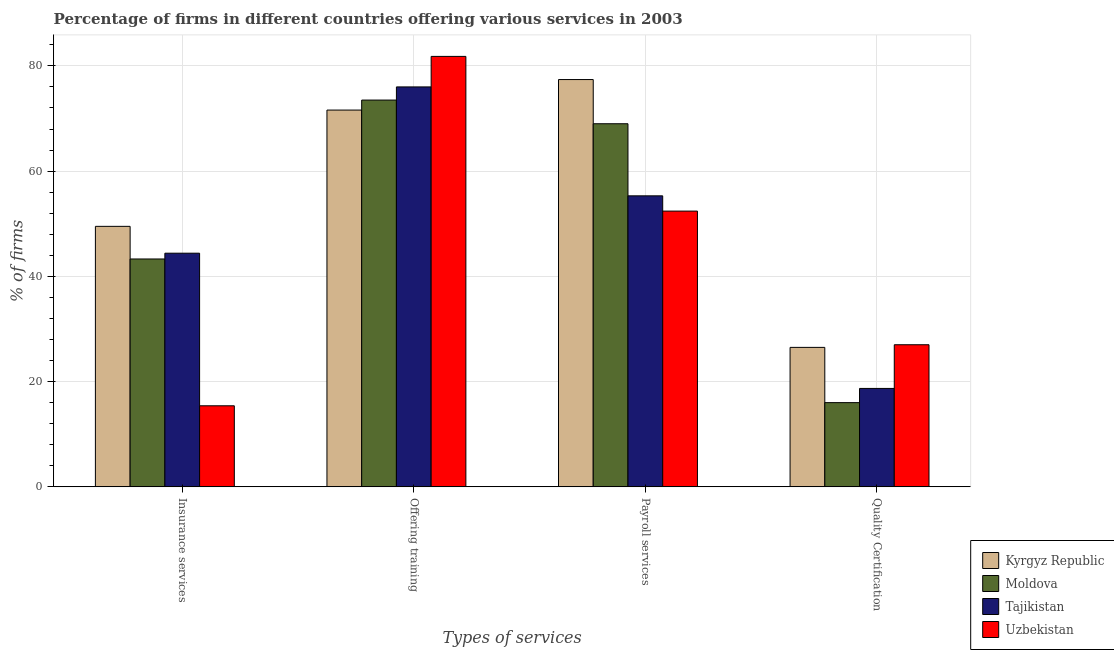How many different coloured bars are there?
Offer a terse response. 4. How many groups of bars are there?
Provide a succinct answer. 4. How many bars are there on the 3rd tick from the right?
Provide a succinct answer. 4. What is the label of the 3rd group of bars from the left?
Your answer should be compact. Payroll services. What is the percentage of firms offering insurance services in Moldova?
Your response must be concise. 43.3. Across all countries, what is the minimum percentage of firms offering insurance services?
Offer a very short reply. 15.4. In which country was the percentage of firms offering insurance services maximum?
Provide a succinct answer. Kyrgyz Republic. In which country was the percentage of firms offering insurance services minimum?
Offer a very short reply. Uzbekistan. What is the total percentage of firms offering payroll services in the graph?
Provide a succinct answer. 254.1. What is the difference between the percentage of firms offering payroll services in Moldova and that in Kyrgyz Republic?
Your answer should be compact. -8.4. What is the difference between the percentage of firms offering insurance services in Uzbekistan and the percentage of firms offering training in Kyrgyz Republic?
Provide a succinct answer. -56.2. What is the average percentage of firms offering quality certification per country?
Keep it short and to the point. 22.05. What is the difference between the percentage of firms offering payroll services and percentage of firms offering insurance services in Tajikistan?
Your answer should be compact. 10.9. In how many countries, is the percentage of firms offering training greater than 52 %?
Make the answer very short. 4. What is the ratio of the percentage of firms offering quality certification in Uzbekistan to that in Kyrgyz Republic?
Keep it short and to the point. 1.02. What is the difference between the highest and the second highest percentage of firms offering payroll services?
Offer a terse response. 8.4. In how many countries, is the percentage of firms offering quality certification greater than the average percentage of firms offering quality certification taken over all countries?
Make the answer very short. 2. What does the 1st bar from the left in Insurance services represents?
Ensure brevity in your answer.  Kyrgyz Republic. What does the 1st bar from the right in Offering training represents?
Give a very brief answer. Uzbekistan. Are all the bars in the graph horizontal?
Offer a very short reply. No. Does the graph contain any zero values?
Offer a terse response. No. Does the graph contain grids?
Offer a terse response. Yes. How many legend labels are there?
Ensure brevity in your answer.  4. How are the legend labels stacked?
Provide a succinct answer. Vertical. What is the title of the graph?
Provide a short and direct response. Percentage of firms in different countries offering various services in 2003. What is the label or title of the X-axis?
Your response must be concise. Types of services. What is the label or title of the Y-axis?
Your response must be concise. % of firms. What is the % of firms in Kyrgyz Republic in Insurance services?
Offer a very short reply. 49.5. What is the % of firms in Moldova in Insurance services?
Ensure brevity in your answer.  43.3. What is the % of firms in Tajikistan in Insurance services?
Offer a very short reply. 44.4. What is the % of firms in Kyrgyz Republic in Offering training?
Your response must be concise. 71.6. What is the % of firms in Moldova in Offering training?
Give a very brief answer. 73.5. What is the % of firms of Uzbekistan in Offering training?
Provide a succinct answer. 81.8. What is the % of firms of Kyrgyz Republic in Payroll services?
Offer a terse response. 77.4. What is the % of firms of Tajikistan in Payroll services?
Make the answer very short. 55.3. What is the % of firms of Uzbekistan in Payroll services?
Provide a succinct answer. 52.4. What is the % of firms in Kyrgyz Republic in Quality Certification?
Your answer should be very brief. 26.5. What is the % of firms in Moldova in Quality Certification?
Offer a very short reply. 16. Across all Types of services, what is the maximum % of firms in Kyrgyz Republic?
Offer a very short reply. 77.4. Across all Types of services, what is the maximum % of firms in Moldova?
Give a very brief answer. 73.5. Across all Types of services, what is the maximum % of firms in Uzbekistan?
Keep it short and to the point. 81.8. Across all Types of services, what is the minimum % of firms of Kyrgyz Republic?
Your answer should be very brief. 26.5. Across all Types of services, what is the minimum % of firms in Tajikistan?
Keep it short and to the point. 18.7. What is the total % of firms in Kyrgyz Republic in the graph?
Keep it short and to the point. 225. What is the total % of firms of Moldova in the graph?
Offer a very short reply. 201.8. What is the total % of firms in Tajikistan in the graph?
Provide a succinct answer. 194.4. What is the total % of firms of Uzbekistan in the graph?
Offer a very short reply. 176.6. What is the difference between the % of firms in Kyrgyz Republic in Insurance services and that in Offering training?
Provide a succinct answer. -22.1. What is the difference between the % of firms of Moldova in Insurance services and that in Offering training?
Offer a terse response. -30.2. What is the difference between the % of firms of Tajikistan in Insurance services and that in Offering training?
Your response must be concise. -31.6. What is the difference between the % of firms in Uzbekistan in Insurance services and that in Offering training?
Provide a succinct answer. -66.4. What is the difference between the % of firms in Kyrgyz Republic in Insurance services and that in Payroll services?
Offer a very short reply. -27.9. What is the difference between the % of firms of Moldova in Insurance services and that in Payroll services?
Provide a short and direct response. -25.7. What is the difference between the % of firms in Uzbekistan in Insurance services and that in Payroll services?
Offer a terse response. -37. What is the difference between the % of firms of Kyrgyz Republic in Insurance services and that in Quality Certification?
Your response must be concise. 23. What is the difference between the % of firms in Moldova in Insurance services and that in Quality Certification?
Ensure brevity in your answer.  27.3. What is the difference between the % of firms of Tajikistan in Insurance services and that in Quality Certification?
Ensure brevity in your answer.  25.7. What is the difference between the % of firms of Tajikistan in Offering training and that in Payroll services?
Your response must be concise. 20.7. What is the difference between the % of firms of Uzbekistan in Offering training and that in Payroll services?
Offer a very short reply. 29.4. What is the difference between the % of firms of Kyrgyz Republic in Offering training and that in Quality Certification?
Your response must be concise. 45.1. What is the difference between the % of firms of Moldova in Offering training and that in Quality Certification?
Give a very brief answer. 57.5. What is the difference between the % of firms of Tajikistan in Offering training and that in Quality Certification?
Keep it short and to the point. 57.3. What is the difference between the % of firms of Uzbekistan in Offering training and that in Quality Certification?
Your answer should be very brief. 54.8. What is the difference between the % of firms in Kyrgyz Republic in Payroll services and that in Quality Certification?
Your response must be concise. 50.9. What is the difference between the % of firms of Moldova in Payroll services and that in Quality Certification?
Keep it short and to the point. 53. What is the difference between the % of firms in Tajikistan in Payroll services and that in Quality Certification?
Give a very brief answer. 36.6. What is the difference between the % of firms of Uzbekistan in Payroll services and that in Quality Certification?
Give a very brief answer. 25.4. What is the difference between the % of firms in Kyrgyz Republic in Insurance services and the % of firms in Moldova in Offering training?
Ensure brevity in your answer.  -24. What is the difference between the % of firms in Kyrgyz Republic in Insurance services and the % of firms in Tajikistan in Offering training?
Give a very brief answer. -26.5. What is the difference between the % of firms of Kyrgyz Republic in Insurance services and the % of firms of Uzbekistan in Offering training?
Offer a very short reply. -32.3. What is the difference between the % of firms of Moldova in Insurance services and the % of firms of Tajikistan in Offering training?
Make the answer very short. -32.7. What is the difference between the % of firms in Moldova in Insurance services and the % of firms in Uzbekistan in Offering training?
Provide a succinct answer. -38.5. What is the difference between the % of firms in Tajikistan in Insurance services and the % of firms in Uzbekistan in Offering training?
Give a very brief answer. -37.4. What is the difference between the % of firms in Kyrgyz Republic in Insurance services and the % of firms in Moldova in Payroll services?
Give a very brief answer. -19.5. What is the difference between the % of firms of Kyrgyz Republic in Insurance services and the % of firms of Tajikistan in Payroll services?
Provide a succinct answer. -5.8. What is the difference between the % of firms in Kyrgyz Republic in Insurance services and the % of firms in Moldova in Quality Certification?
Provide a short and direct response. 33.5. What is the difference between the % of firms of Kyrgyz Republic in Insurance services and the % of firms of Tajikistan in Quality Certification?
Give a very brief answer. 30.8. What is the difference between the % of firms in Kyrgyz Republic in Insurance services and the % of firms in Uzbekistan in Quality Certification?
Provide a short and direct response. 22.5. What is the difference between the % of firms in Moldova in Insurance services and the % of firms in Tajikistan in Quality Certification?
Your answer should be very brief. 24.6. What is the difference between the % of firms in Moldova in Insurance services and the % of firms in Uzbekistan in Quality Certification?
Provide a succinct answer. 16.3. What is the difference between the % of firms in Tajikistan in Insurance services and the % of firms in Uzbekistan in Quality Certification?
Keep it short and to the point. 17.4. What is the difference between the % of firms of Kyrgyz Republic in Offering training and the % of firms of Tajikistan in Payroll services?
Provide a short and direct response. 16.3. What is the difference between the % of firms in Moldova in Offering training and the % of firms in Tajikistan in Payroll services?
Your answer should be very brief. 18.2. What is the difference between the % of firms in Moldova in Offering training and the % of firms in Uzbekistan in Payroll services?
Ensure brevity in your answer.  21.1. What is the difference between the % of firms of Tajikistan in Offering training and the % of firms of Uzbekistan in Payroll services?
Your response must be concise. 23.6. What is the difference between the % of firms in Kyrgyz Republic in Offering training and the % of firms in Moldova in Quality Certification?
Your response must be concise. 55.6. What is the difference between the % of firms of Kyrgyz Republic in Offering training and the % of firms of Tajikistan in Quality Certification?
Keep it short and to the point. 52.9. What is the difference between the % of firms of Kyrgyz Republic in Offering training and the % of firms of Uzbekistan in Quality Certification?
Give a very brief answer. 44.6. What is the difference between the % of firms of Moldova in Offering training and the % of firms of Tajikistan in Quality Certification?
Provide a short and direct response. 54.8. What is the difference between the % of firms in Moldova in Offering training and the % of firms in Uzbekistan in Quality Certification?
Give a very brief answer. 46.5. What is the difference between the % of firms in Tajikistan in Offering training and the % of firms in Uzbekistan in Quality Certification?
Make the answer very short. 49. What is the difference between the % of firms in Kyrgyz Republic in Payroll services and the % of firms in Moldova in Quality Certification?
Provide a short and direct response. 61.4. What is the difference between the % of firms of Kyrgyz Republic in Payroll services and the % of firms of Tajikistan in Quality Certification?
Your answer should be very brief. 58.7. What is the difference between the % of firms of Kyrgyz Republic in Payroll services and the % of firms of Uzbekistan in Quality Certification?
Offer a very short reply. 50.4. What is the difference between the % of firms of Moldova in Payroll services and the % of firms of Tajikistan in Quality Certification?
Give a very brief answer. 50.3. What is the difference between the % of firms of Tajikistan in Payroll services and the % of firms of Uzbekistan in Quality Certification?
Make the answer very short. 28.3. What is the average % of firms of Kyrgyz Republic per Types of services?
Make the answer very short. 56.25. What is the average % of firms of Moldova per Types of services?
Your answer should be compact. 50.45. What is the average % of firms in Tajikistan per Types of services?
Your answer should be compact. 48.6. What is the average % of firms in Uzbekistan per Types of services?
Your answer should be compact. 44.15. What is the difference between the % of firms of Kyrgyz Republic and % of firms of Uzbekistan in Insurance services?
Make the answer very short. 34.1. What is the difference between the % of firms of Moldova and % of firms of Tajikistan in Insurance services?
Keep it short and to the point. -1.1. What is the difference between the % of firms in Moldova and % of firms in Uzbekistan in Insurance services?
Your answer should be very brief. 27.9. What is the difference between the % of firms of Tajikistan and % of firms of Uzbekistan in Insurance services?
Your answer should be compact. 29. What is the difference between the % of firms of Moldova and % of firms of Uzbekistan in Offering training?
Provide a succinct answer. -8.3. What is the difference between the % of firms of Kyrgyz Republic and % of firms of Tajikistan in Payroll services?
Give a very brief answer. 22.1. What is the difference between the % of firms of Moldova and % of firms of Tajikistan in Payroll services?
Your answer should be very brief. 13.7. What is the difference between the % of firms of Moldova and % of firms of Uzbekistan in Quality Certification?
Your response must be concise. -11. What is the ratio of the % of firms in Kyrgyz Republic in Insurance services to that in Offering training?
Give a very brief answer. 0.69. What is the ratio of the % of firms in Moldova in Insurance services to that in Offering training?
Keep it short and to the point. 0.59. What is the ratio of the % of firms of Tajikistan in Insurance services to that in Offering training?
Offer a very short reply. 0.58. What is the ratio of the % of firms of Uzbekistan in Insurance services to that in Offering training?
Ensure brevity in your answer.  0.19. What is the ratio of the % of firms in Kyrgyz Republic in Insurance services to that in Payroll services?
Your answer should be compact. 0.64. What is the ratio of the % of firms of Moldova in Insurance services to that in Payroll services?
Provide a short and direct response. 0.63. What is the ratio of the % of firms of Tajikistan in Insurance services to that in Payroll services?
Your answer should be compact. 0.8. What is the ratio of the % of firms of Uzbekistan in Insurance services to that in Payroll services?
Give a very brief answer. 0.29. What is the ratio of the % of firms in Kyrgyz Republic in Insurance services to that in Quality Certification?
Make the answer very short. 1.87. What is the ratio of the % of firms in Moldova in Insurance services to that in Quality Certification?
Offer a very short reply. 2.71. What is the ratio of the % of firms in Tajikistan in Insurance services to that in Quality Certification?
Give a very brief answer. 2.37. What is the ratio of the % of firms in Uzbekistan in Insurance services to that in Quality Certification?
Offer a very short reply. 0.57. What is the ratio of the % of firms of Kyrgyz Republic in Offering training to that in Payroll services?
Your answer should be very brief. 0.93. What is the ratio of the % of firms in Moldova in Offering training to that in Payroll services?
Your answer should be compact. 1.07. What is the ratio of the % of firms of Tajikistan in Offering training to that in Payroll services?
Offer a very short reply. 1.37. What is the ratio of the % of firms of Uzbekistan in Offering training to that in Payroll services?
Offer a terse response. 1.56. What is the ratio of the % of firms of Kyrgyz Republic in Offering training to that in Quality Certification?
Your answer should be compact. 2.7. What is the ratio of the % of firms in Moldova in Offering training to that in Quality Certification?
Give a very brief answer. 4.59. What is the ratio of the % of firms in Tajikistan in Offering training to that in Quality Certification?
Your answer should be compact. 4.06. What is the ratio of the % of firms in Uzbekistan in Offering training to that in Quality Certification?
Your answer should be very brief. 3.03. What is the ratio of the % of firms in Kyrgyz Republic in Payroll services to that in Quality Certification?
Your answer should be very brief. 2.92. What is the ratio of the % of firms of Moldova in Payroll services to that in Quality Certification?
Offer a terse response. 4.31. What is the ratio of the % of firms of Tajikistan in Payroll services to that in Quality Certification?
Keep it short and to the point. 2.96. What is the ratio of the % of firms of Uzbekistan in Payroll services to that in Quality Certification?
Provide a succinct answer. 1.94. What is the difference between the highest and the second highest % of firms in Moldova?
Your answer should be compact. 4.5. What is the difference between the highest and the second highest % of firms in Tajikistan?
Make the answer very short. 20.7. What is the difference between the highest and the second highest % of firms in Uzbekistan?
Give a very brief answer. 29.4. What is the difference between the highest and the lowest % of firms of Kyrgyz Republic?
Your answer should be very brief. 50.9. What is the difference between the highest and the lowest % of firms in Moldova?
Keep it short and to the point. 57.5. What is the difference between the highest and the lowest % of firms of Tajikistan?
Keep it short and to the point. 57.3. What is the difference between the highest and the lowest % of firms of Uzbekistan?
Provide a short and direct response. 66.4. 